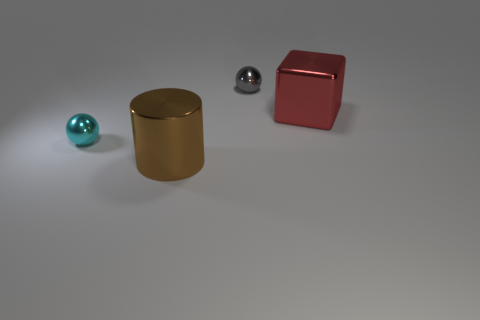Add 4 small cyan rubber objects. How many objects exist? 8 Subtract all cylinders. How many objects are left? 3 Subtract all tiny metal balls. Subtract all large things. How many objects are left? 0 Add 1 red shiny objects. How many red shiny objects are left? 2 Add 4 small blue rubber cylinders. How many small blue rubber cylinders exist? 4 Subtract 1 cyan spheres. How many objects are left? 3 